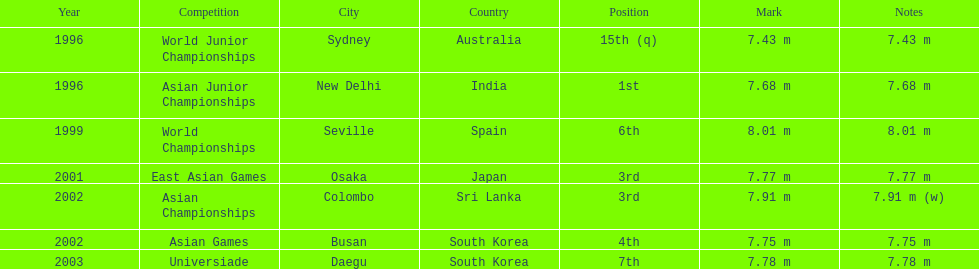What is the difference between the number of times the position of third was achieved and the number of times the position of first was achieved? 1. 